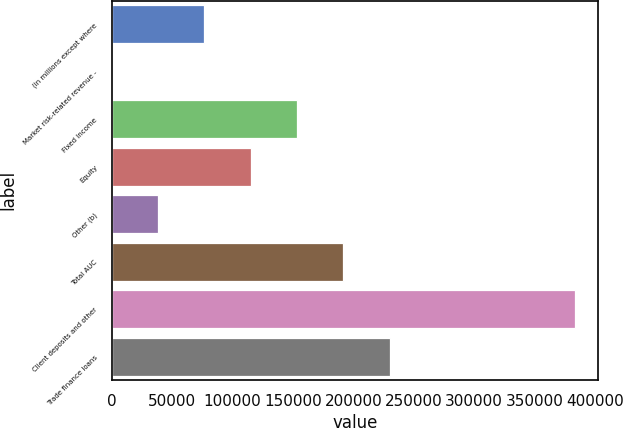<chart> <loc_0><loc_0><loc_500><loc_500><bar_chart><fcel>(in millions except where<fcel>Market risk-related revenue -<fcel>Fixed Income<fcel>Equity<fcel>Other (b)<fcel>Total AUC<fcel>Client deposits and other<fcel>Trade finance loans<nl><fcel>76734.8<fcel>1.79<fcel>153468<fcel>115101<fcel>38368.3<fcel>191834<fcel>383667<fcel>230201<nl></chart> 